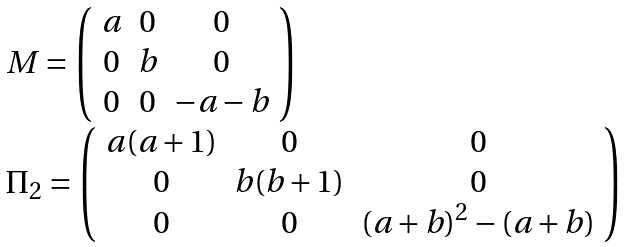<formula> <loc_0><loc_0><loc_500><loc_500>\begin{array} { l } M = \left ( \begin{array} [ p o s ] { c c c } a & 0 & 0 \\ 0 & b & 0 \\ 0 & 0 & - a - b \\ \end{array} \right ) \\ \Pi _ { 2 } = \left ( \begin{array} [ p o s ] { c c c } a ( a + 1 ) & 0 & 0 \\ 0 & b ( b + 1 ) & 0 \\ 0 & 0 & ( a + b ) ^ { 2 } - ( a + b ) \\ \end{array} \right ) \\ \end{array}</formula> 